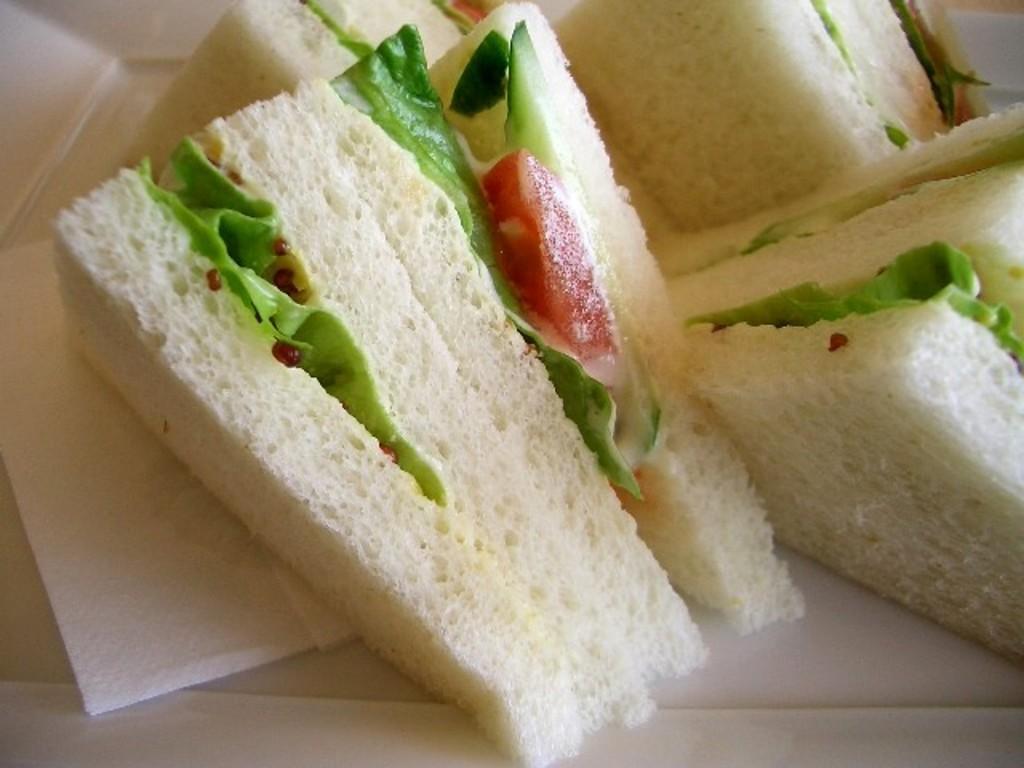How would you summarize this image in a sentence or two? In this image we can see stuffed sandwiches and tissue papers. 